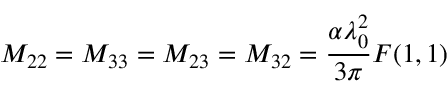Convert formula to latex. <formula><loc_0><loc_0><loc_500><loc_500>M _ { 2 2 } = M _ { 3 3 } = M _ { 2 3 } = M _ { 3 2 } = \frac { \alpha \lambda _ { 0 } ^ { 2 } } { 3 \pi } F ( 1 , 1 )</formula> 